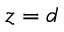<formula> <loc_0><loc_0><loc_500><loc_500>z = d</formula> 